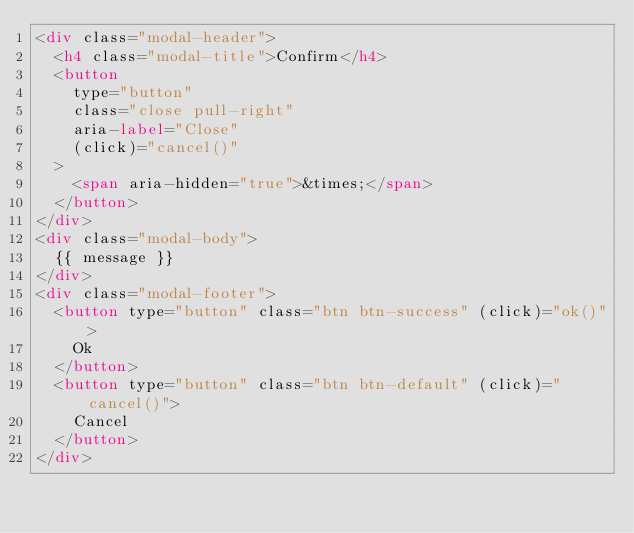Convert code to text. <code><loc_0><loc_0><loc_500><loc_500><_HTML_><div class="modal-header">
  <h4 class="modal-title">Confirm</h4>
  <button
    type="button"
    class="close pull-right"
    aria-label="Close"
    (click)="cancel()"
  >
    <span aria-hidden="true">&times;</span>
  </button>
</div>
<div class="modal-body">
  {{ message }}
</div>
<div class="modal-footer">
  <button type="button" class="btn btn-success" (click)="ok()">
    Ok
  </button>
  <button type="button" class="btn btn-default" (click)="cancel()">
    Cancel
  </button>
</div>
</code> 